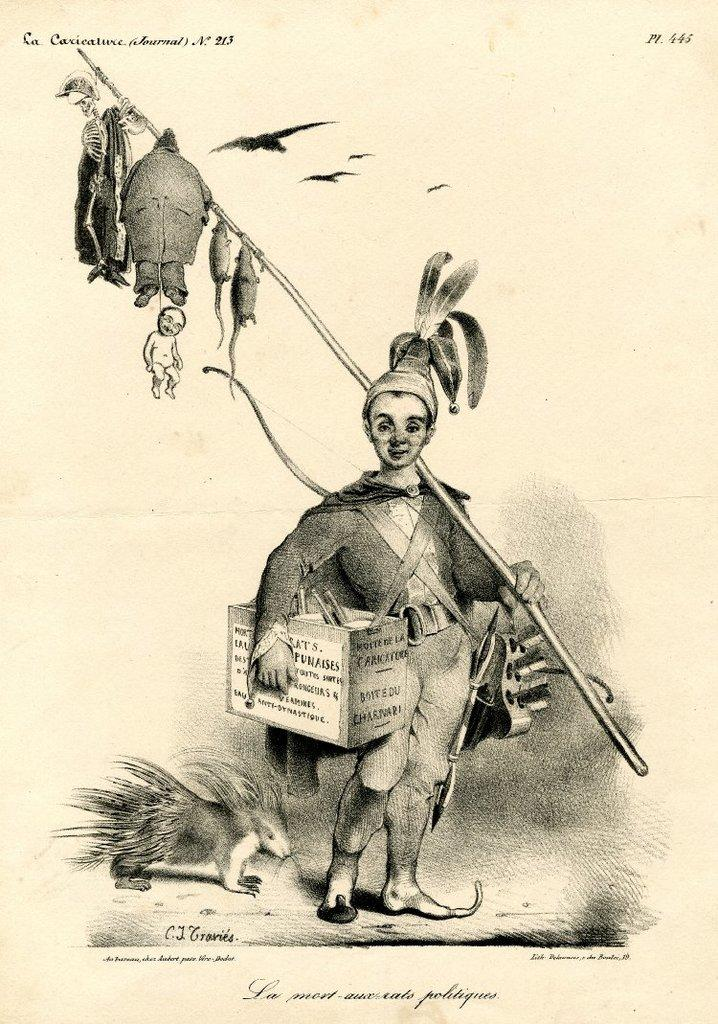What is the boy in the drawing holding? The boy is holding a box and a stick. What is attached to the stick in the drawing? A skeleton, rats, and a man are hanging from the stick. Are there any animals in the drawing? Yes, there are birds flying in the drawing, and there is an animal on the left side of the drawing. What color is the deer's tongue in the drawing? There is no deer present in the drawing, so it is not possible to determine the color of its tongue. 